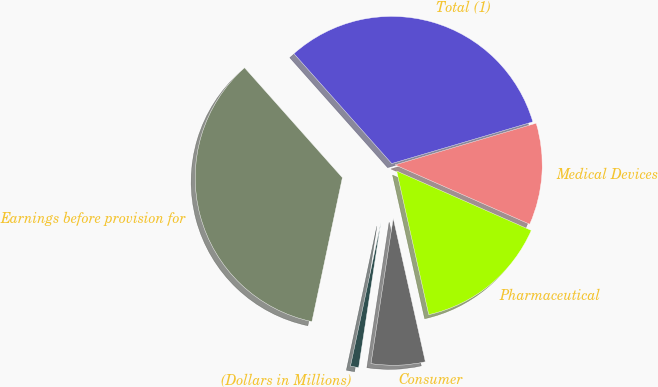Convert chart. <chart><loc_0><loc_0><loc_500><loc_500><pie_chart><fcel>(Dollars in Millions)<fcel>Consumer<fcel>Pharmaceutical<fcel>Medical Devices<fcel>Total (1)<fcel>Earnings before provision for<nl><fcel>0.9%<fcel>5.92%<fcel>14.89%<fcel>11.18%<fcel>32.0%<fcel>35.11%<nl></chart> 